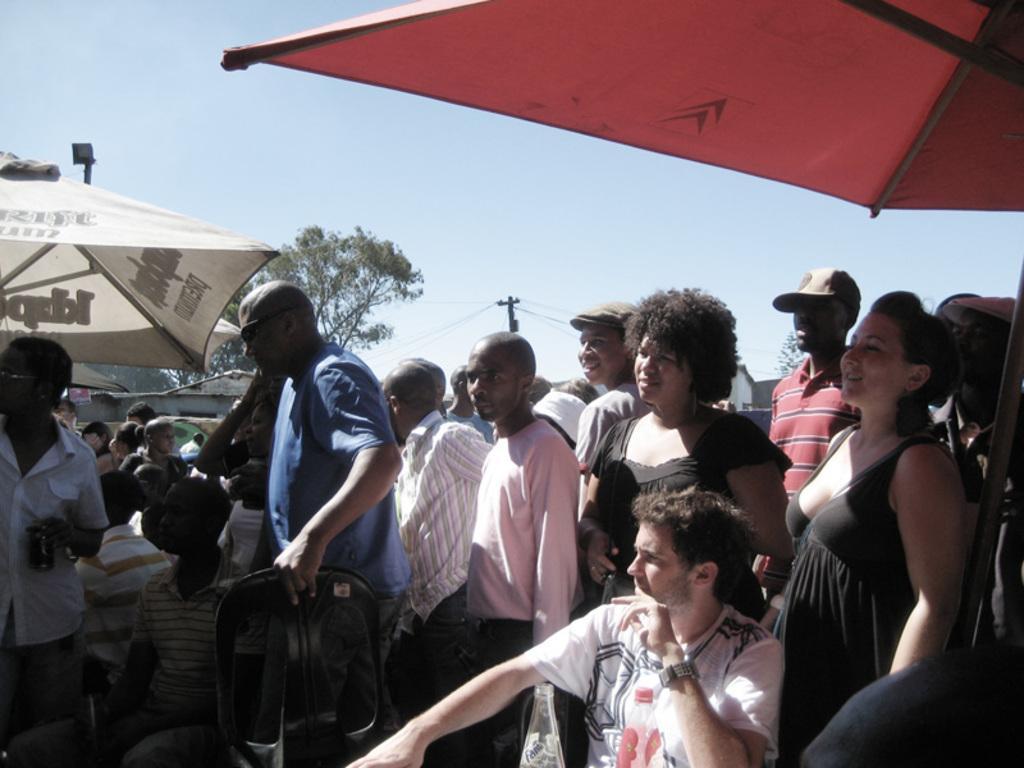In one or two sentences, can you explain what this image depicts? There is a group of persons standing as we can see in the middle of this image. There is one person sitting and wearing a white color t shirt at the bottom of this image. There are some trees and a current pole in the background. There is a sky at the top of this image. 